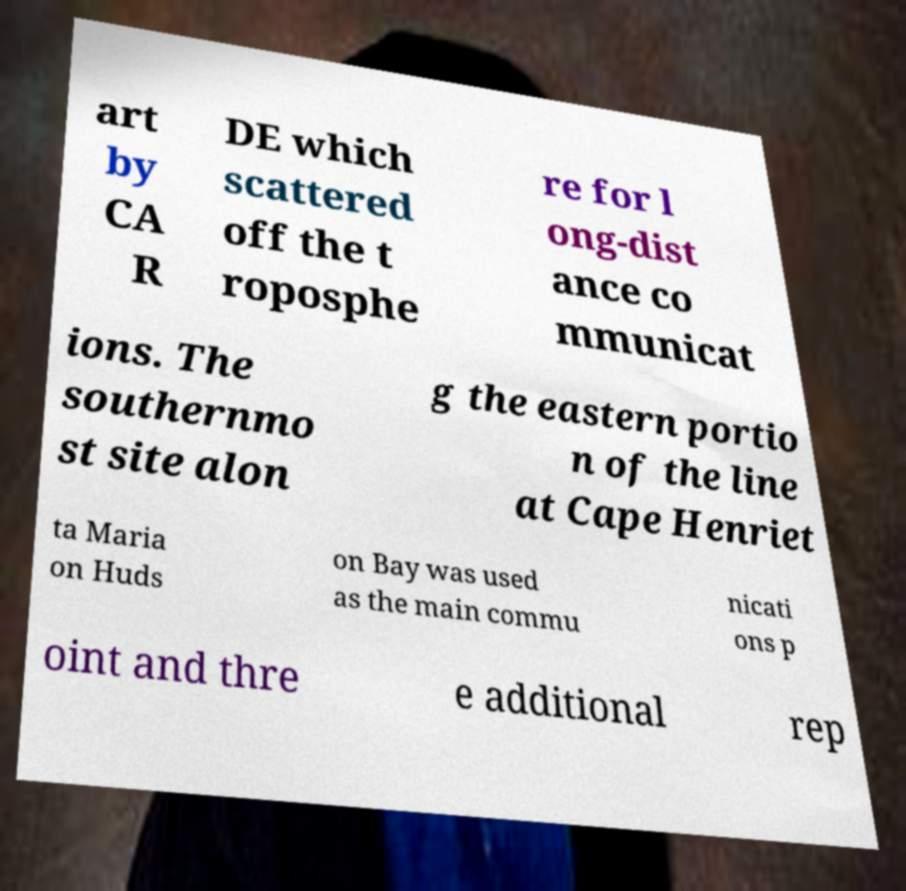Can you accurately transcribe the text from the provided image for me? art by CA R DE which scattered off the t roposphe re for l ong-dist ance co mmunicat ions. The southernmo st site alon g the eastern portio n of the line at Cape Henriet ta Maria on Huds on Bay was used as the main commu nicati ons p oint and thre e additional rep 